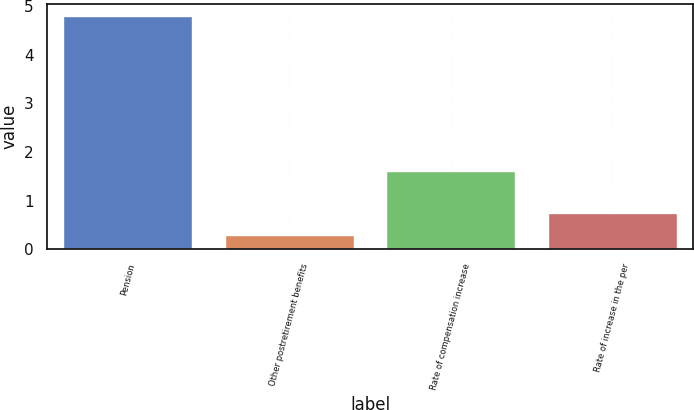<chart> <loc_0><loc_0><loc_500><loc_500><bar_chart><fcel>Pension<fcel>Other postretirement benefits<fcel>Rate of compensation increase<fcel>Rate of increase in the per<nl><fcel>4.8<fcel>0.3<fcel>1.6<fcel>0.75<nl></chart> 